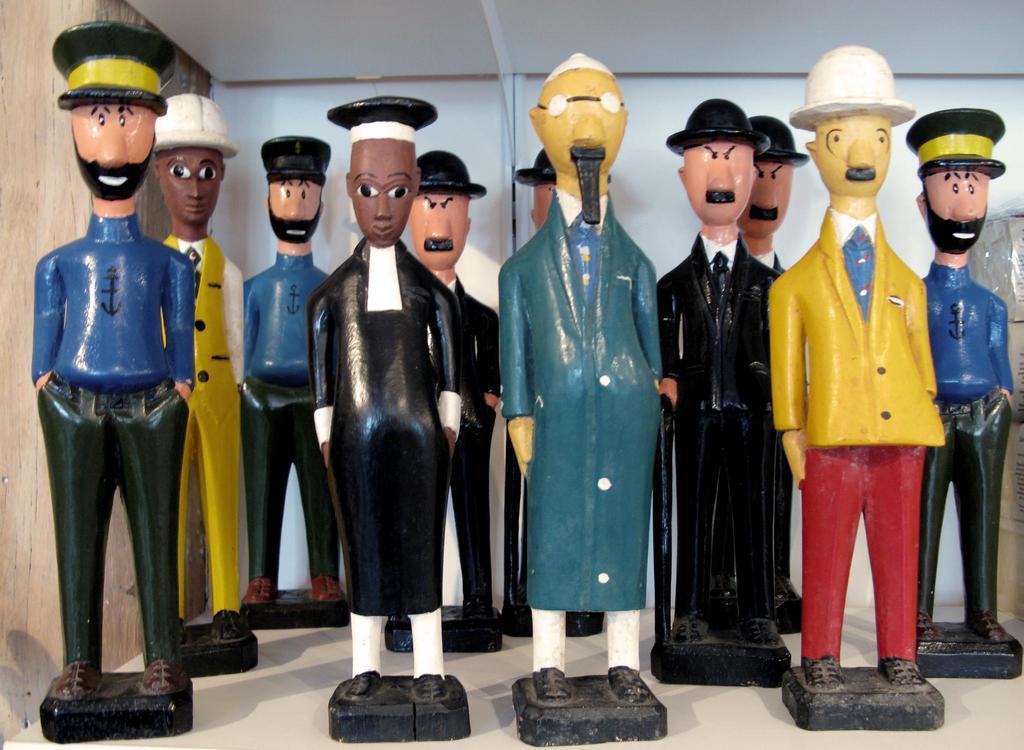Can you describe this image briefly? In this image we can see some toys, wearing caps, on the surface. 